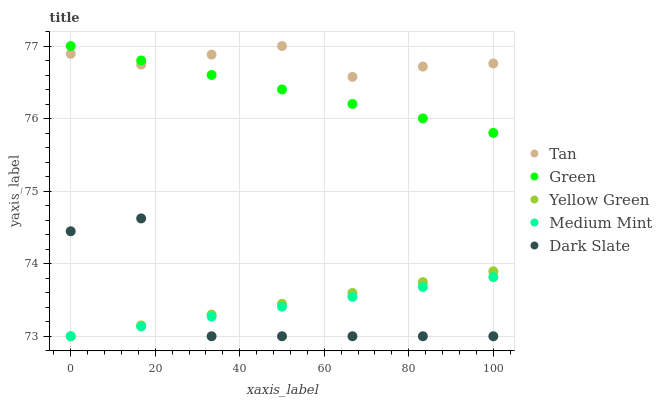Does Dark Slate have the minimum area under the curve?
Answer yes or no. Yes. Does Tan have the maximum area under the curve?
Answer yes or no. Yes. Does Tan have the minimum area under the curve?
Answer yes or no. No. Does Dark Slate have the maximum area under the curve?
Answer yes or no. No. Is Medium Mint the smoothest?
Answer yes or no. Yes. Is Dark Slate the roughest?
Answer yes or no. Yes. Is Tan the smoothest?
Answer yes or no. No. Is Tan the roughest?
Answer yes or no. No. Does Medium Mint have the lowest value?
Answer yes or no. Yes. Does Tan have the lowest value?
Answer yes or no. No. Does Green have the highest value?
Answer yes or no. Yes. Does Dark Slate have the highest value?
Answer yes or no. No. Is Medium Mint less than Tan?
Answer yes or no. Yes. Is Tan greater than Yellow Green?
Answer yes or no. Yes. Does Medium Mint intersect Yellow Green?
Answer yes or no. Yes. Is Medium Mint less than Yellow Green?
Answer yes or no. No. Is Medium Mint greater than Yellow Green?
Answer yes or no. No. Does Medium Mint intersect Tan?
Answer yes or no. No. 